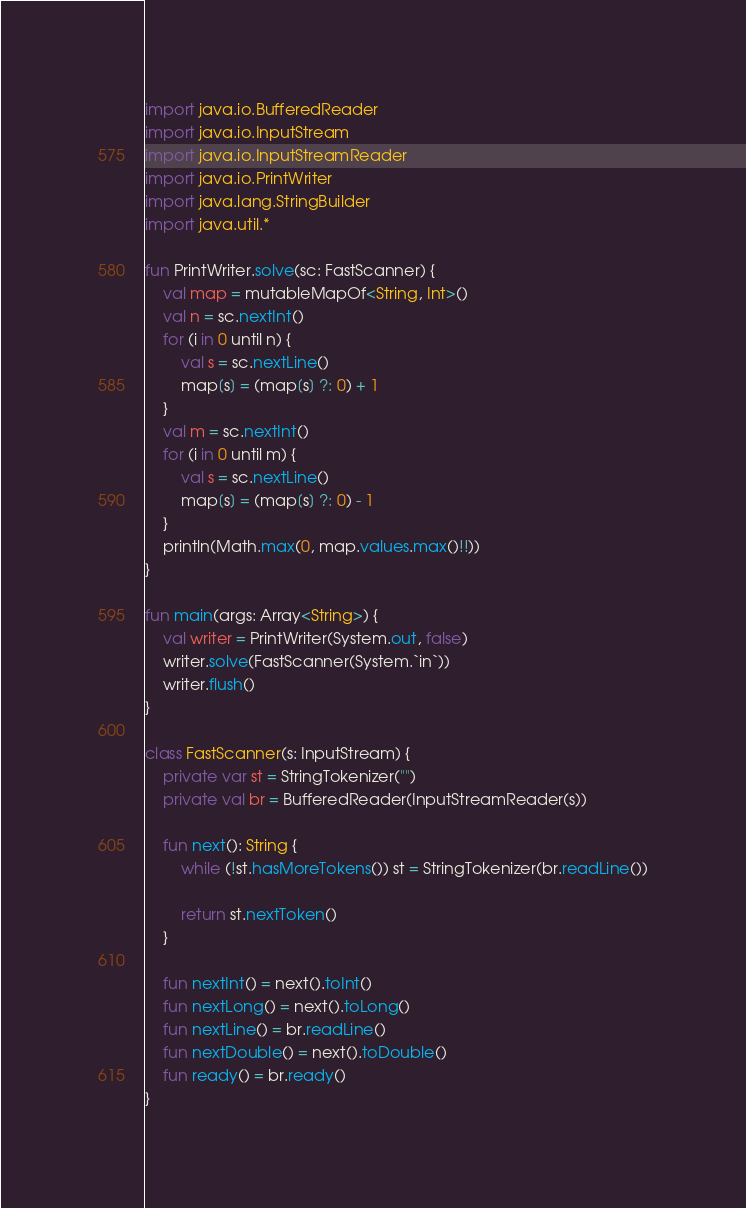<code> <loc_0><loc_0><loc_500><loc_500><_Kotlin_>import java.io.BufferedReader
import java.io.InputStream
import java.io.InputStreamReader
import java.io.PrintWriter
import java.lang.StringBuilder
import java.util.*

fun PrintWriter.solve(sc: FastScanner) {
    val map = mutableMapOf<String, Int>()
    val n = sc.nextInt()
    for (i in 0 until n) {
        val s = sc.nextLine()
        map[s] = (map[s] ?: 0) + 1
    }
    val m = sc.nextInt()
    for (i in 0 until m) {
        val s = sc.nextLine()
        map[s] = (map[s] ?: 0) - 1
    }
    println(Math.max(0, map.values.max()!!))
}

fun main(args: Array<String>) {
    val writer = PrintWriter(System.out, false)
    writer.solve(FastScanner(System.`in`))
    writer.flush()
}

class FastScanner(s: InputStream) {
    private var st = StringTokenizer("")
    private val br = BufferedReader(InputStreamReader(s))

    fun next(): String {
        while (!st.hasMoreTokens()) st = StringTokenizer(br.readLine())

        return st.nextToken()
    }

    fun nextInt() = next().toInt()
    fun nextLong() = next().toLong()
    fun nextLine() = br.readLine()
    fun nextDouble() = next().toDouble()
    fun ready() = br.ready()
}
</code> 